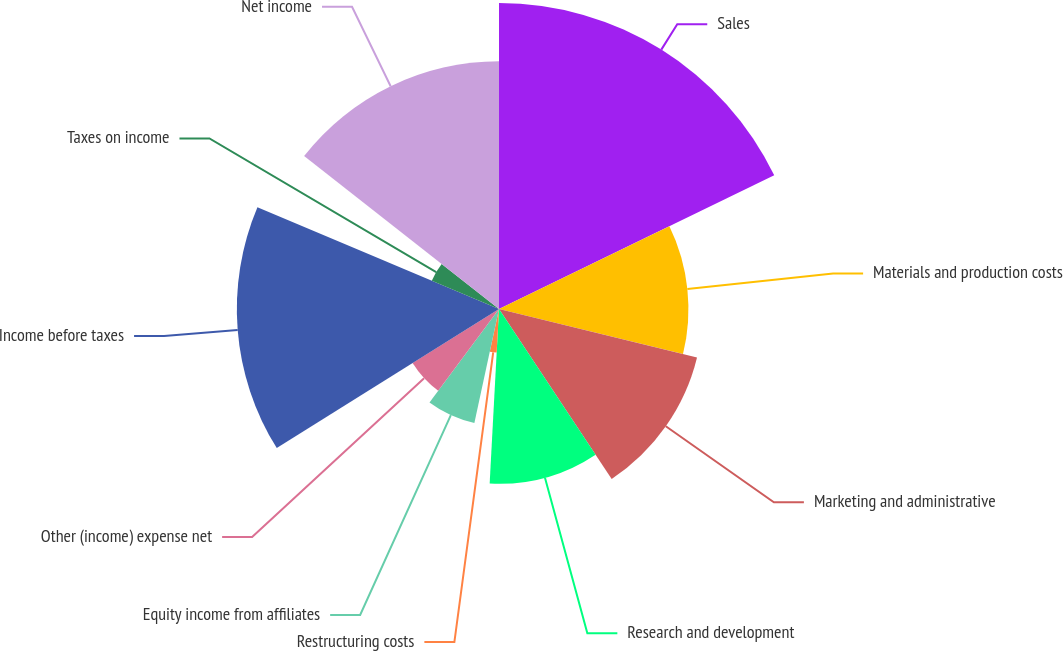Convert chart. <chart><loc_0><loc_0><loc_500><loc_500><pie_chart><fcel>Sales<fcel>Materials and production costs<fcel>Marketing and administrative<fcel>Research and development<fcel>Restructuring costs<fcel>Equity income from affiliates<fcel>Other (income) expense net<fcel>Income before taxes<fcel>Taxes on income<fcel>Net income<nl><fcel>17.8%<fcel>11.02%<fcel>11.86%<fcel>10.17%<fcel>2.54%<fcel>6.78%<fcel>5.93%<fcel>15.25%<fcel>4.24%<fcel>14.41%<nl></chart> 